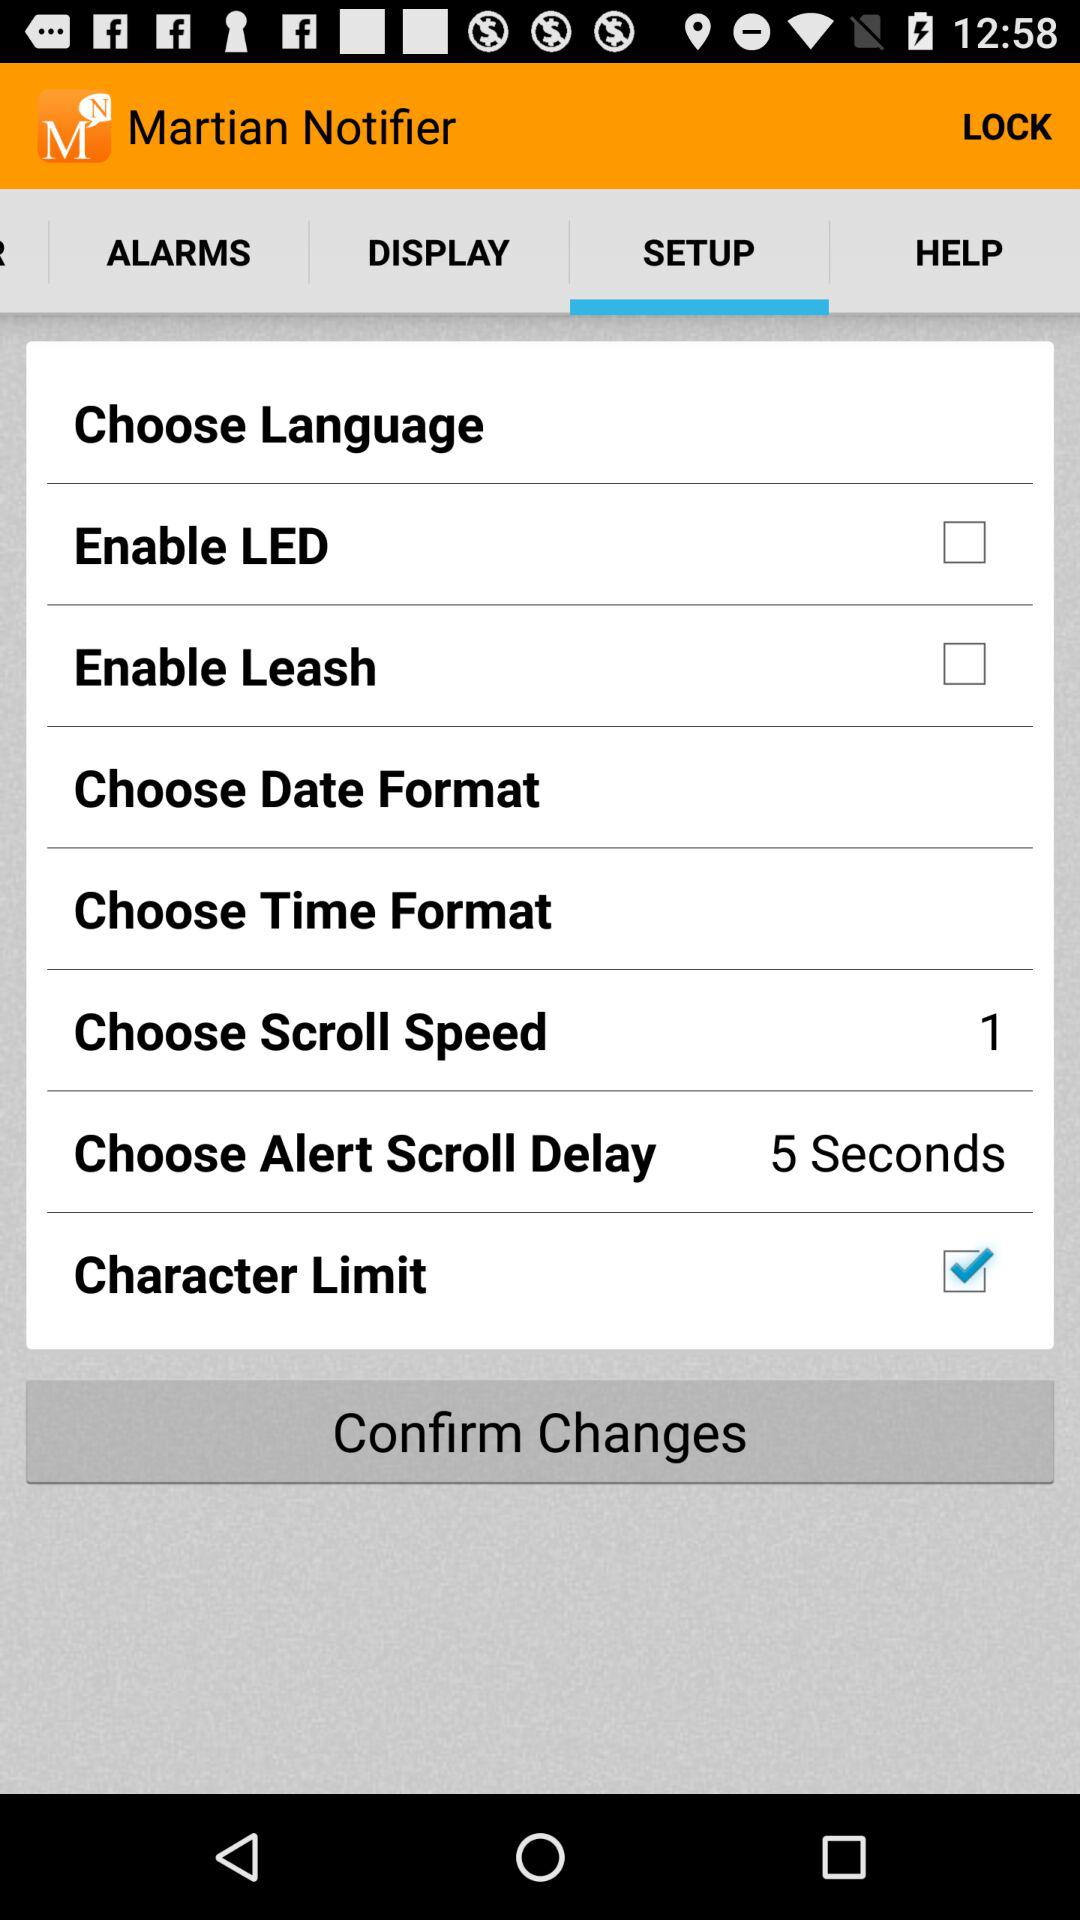How many items in the setup menu are not checkboxes?
Answer the question using a single word or phrase. 4 